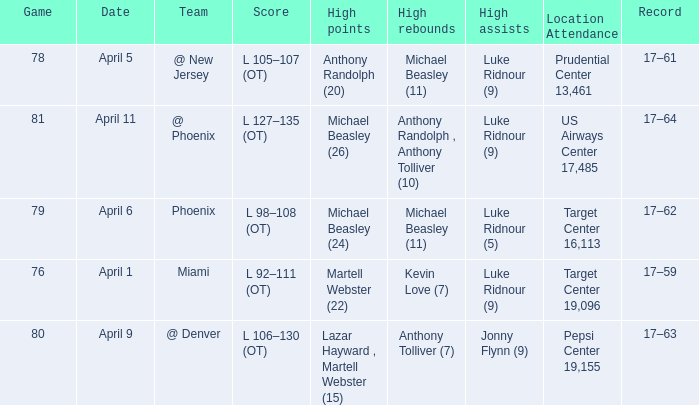In how many different games did Luke Ridnour (5) did the most high assists? 1.0. 